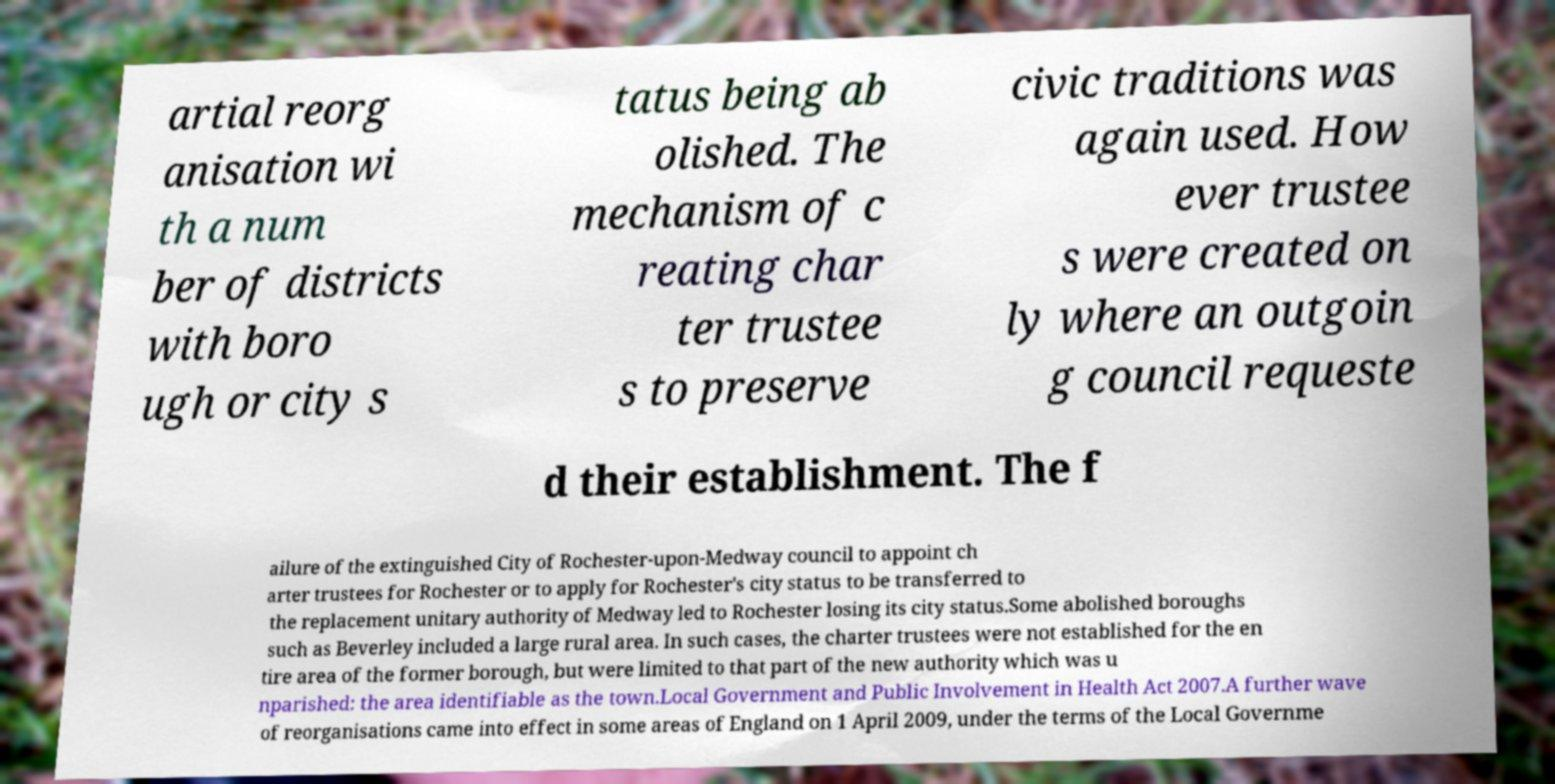Can you accurately transcribe the text from the provided image for me? artial reorg anisation wi th a num ber of districts with boro ugh or city s tatus being ab olished. The mechanism of c reating char ter trustee s to preserve civic traditions was again used. How ever trustee s were created on ly where an outgoin g council requeste d their establishment. The f ailure of the extinguished City of Rochester-upon-Medway council to appoint ch arter trustees for Rochester or to apply for Rochester's city status to be transferred to the replacement unitary authority of Medway led to Rochester losing its city status.Some abolished boroughs such as Beverley included a large rural area. In such cases, the charter trustees were not established for the en tire area of the former borough, but were limited to that part of the new authority which was u nparished: the area identifiable as the town.Local Government and Public Involvement in Health Act 2007.A further wave of reorganisations came into effect in some areas of England on 1 April 2009, under the terms of the Local Governme 